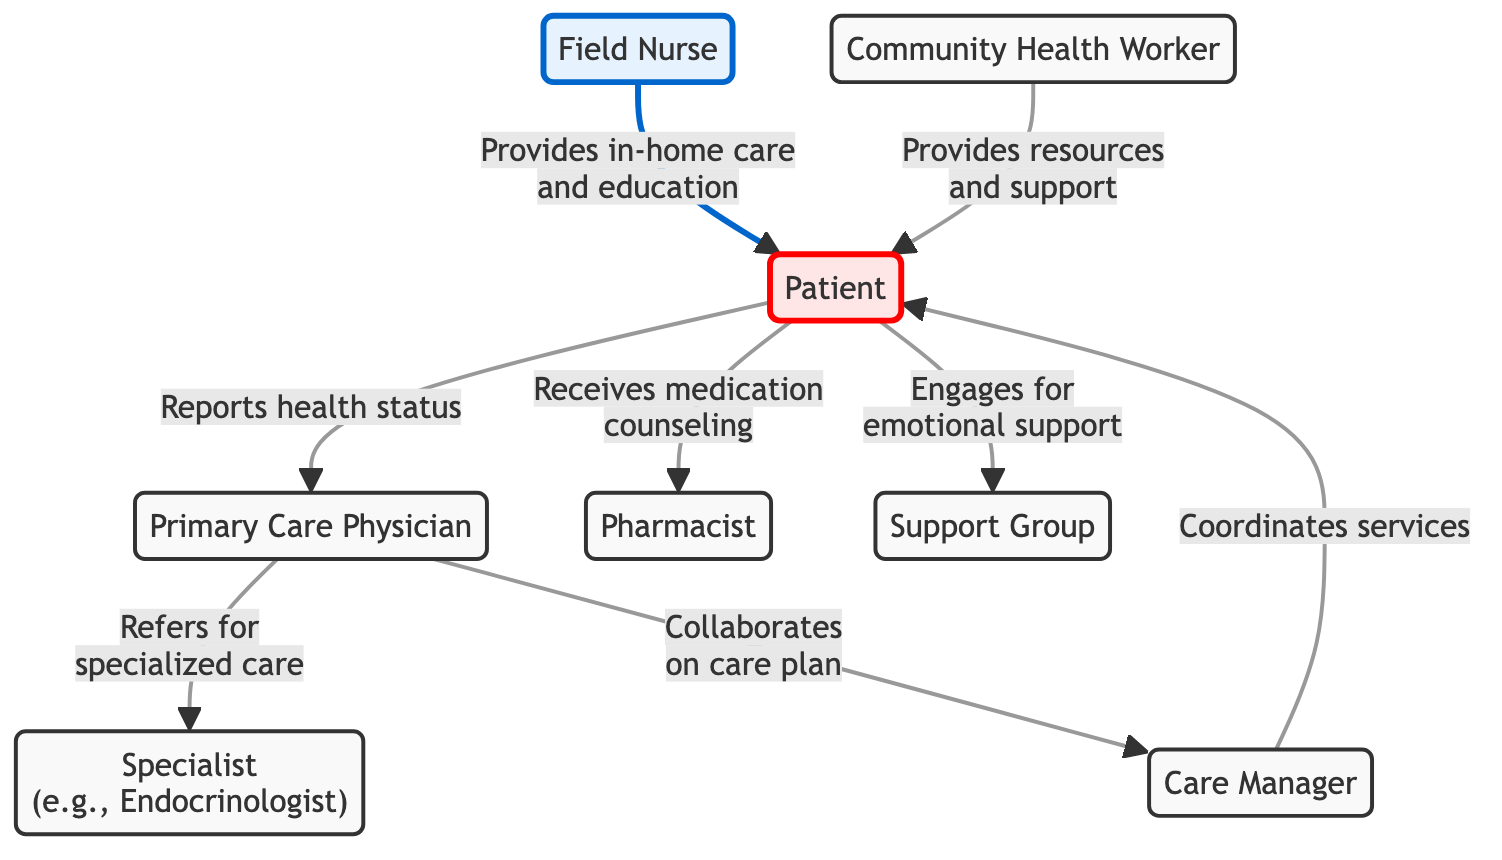What role does the Field Nurse play in chronic disease management? The Field Nurse provides in-home care and education to the Patient, as depicted by the directed edge from the Field Nurse to the Patient in the diagram.
Answer: Provides in-home care and education How many edges are there in total in the diagram? By counting the directed connections or edges indicated in the diagram, we find that there are a total of 8 edges.
Answer: 8 Who does the Primary Care Physician refer the Patient to for specialized care? The diagram shows that the Primary Care Physician has a directed edge to the Specialist labeled "Refers for specialized care," indicating that the Specialist is the recipient of the referral.
Answer: Specialist What is the main responsibility of the Care Manager? The Care Manager coordinates services for the Patient, which is indicated by the directed edge from Care Manager to Patient labeled "Coordinates services."
Answer: Coordinates services How many healthcare professionals are involved in the flow of care for the Patient? The diagram lists six distinct health professionals connected to the Patient: Field Nurse, Primary Care Physician, Specialist, Care Manager, Pharmacist, and Community Health Worker. Thus, the total is 6.
Answer: 6 What does the Patient report to the Primary Care Physician? According to the directed edge from Patient to Primary Care Physician, the Patient reports their health status.
Answer: Reports health status Who provides emotional support to the Patient? The directed edge from Patient to Support Group indicates that the Support Group is where the Patient engages for emotional support.
Answer: Support Group What type of health professional collaborates on the care plan with the Primary Care Physician? The diagram shows a directed edge from the Primary Care Physician to the Care Manager, indicating that the Care Manager is the individual collaborating on the care plan.
Answer: Care Manager 